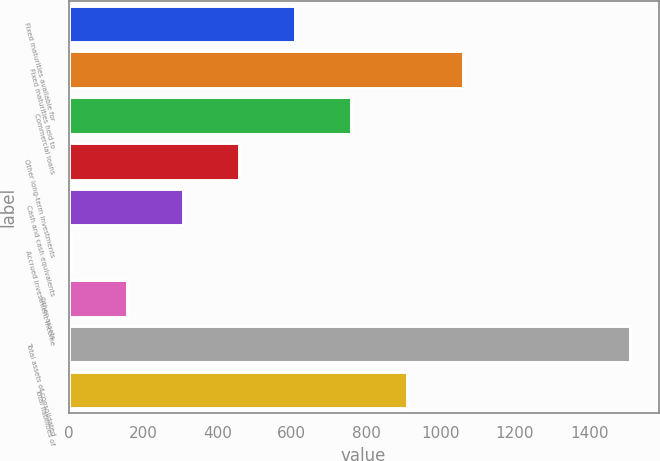<chart> <loc_0><loc_0><loc_500><loc_500><bar_chart><fcel>Fixed maturities available for<fcel>Fixed maturities held to<fcel>Commercial loans<fcel>Other long-term investments<fcel>Cash and cash equivalents<fcel>Accrued investment income<fcel>Other assets<fcel>Total assets of consolidated<fcel>Total liabilities of<nl><fcel>608<fcel>1059.5<fcel>758.5<fcel>457.5<fcel>307<fcel>6<fcel>156.5<fcel>1511<fcel>909<nl></chart> 